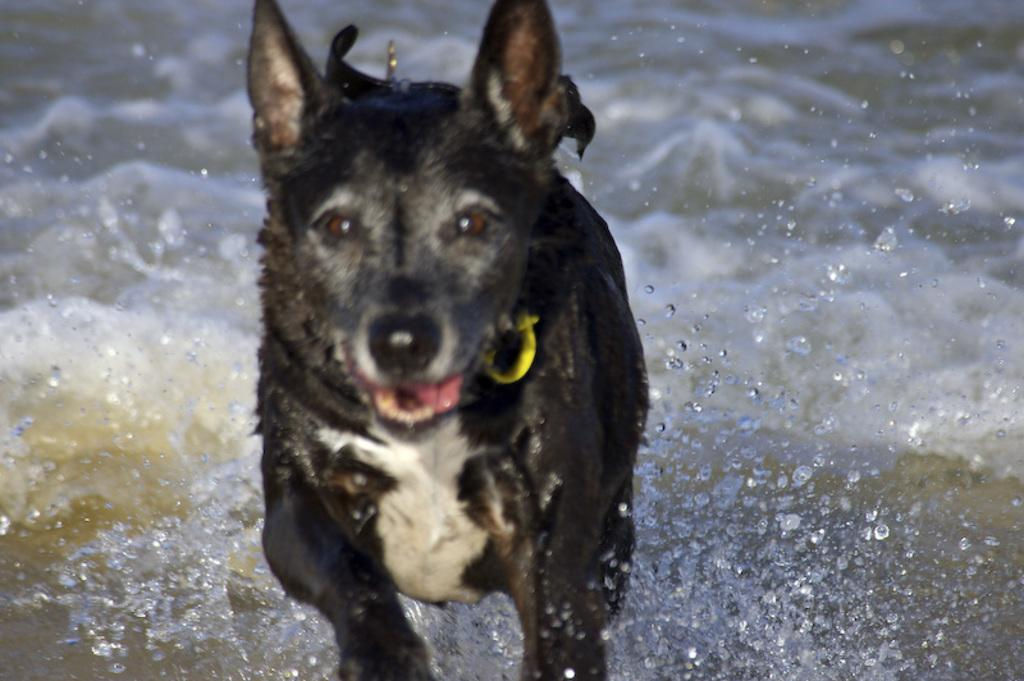What type of animal is present in the image? There is a dog in the image. What can be seen in the background or surrounding the dog? Water is visible in the image. What type of trousers is the dog wearing in the image? Dogs do not wear trousers, so this detail cannot be found in the image. 